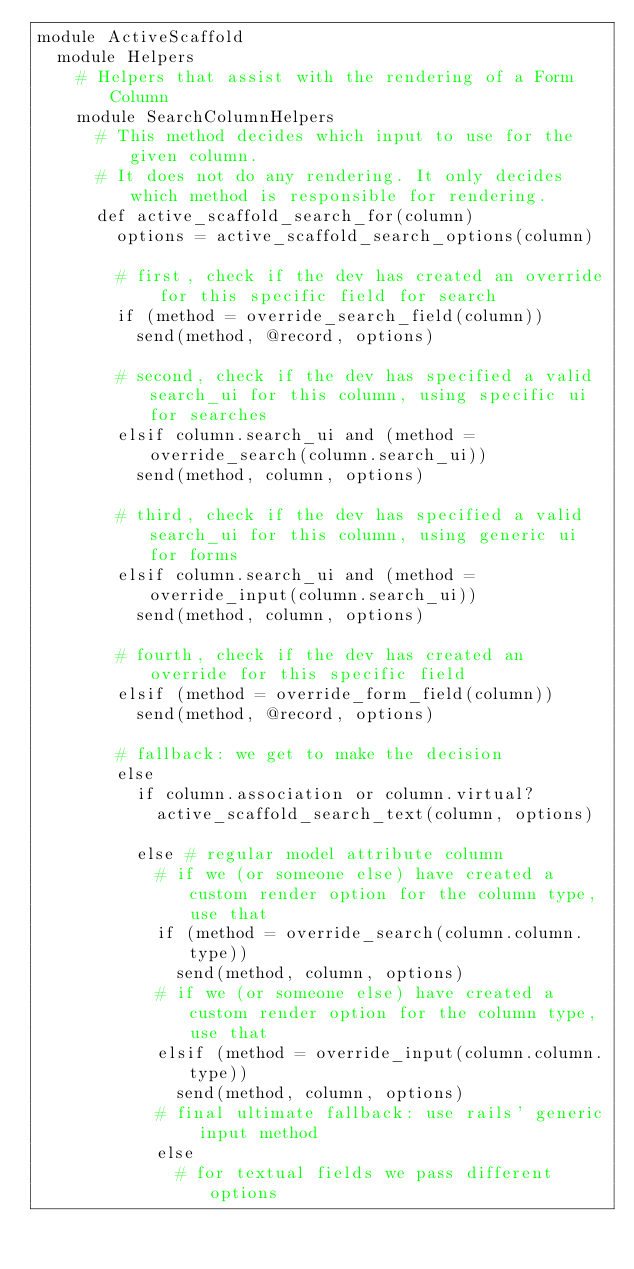<code> <loc_0><loc_0><loc_500><loc_500><_Ruby_>module ActiveScaffold
  module Helpers
    # Helpers that assist with the rendering of a Form Column
    module SearchColumnHelpers
      # This method decides which input to use for the given column.
      # It does not do any rendering. It only decides which method is responsible for rendering.
      def active_scaffold_search_for(column)
        options = active_scaffold_search_options(column)

        # first, check if the dev has created an override for this specific field for search
        if (method = override_search_field(column))
          send(method, @record, options)

        # second, check if the dev has specified a valid search_ui for this column, using specific ui for searches
        elsif column.search_ui and (method = override_search(column.search_ui))
          send(method, column, options)

        # third, check if the dev has specified a valid search_ui for this column, using generic ui for forms
        elsif column.search_ui and (method = override_input(column.search_ui))
          send(method, column, options)

        # fourth, check if the dev has created an override for this specific field
        elsif (method = override_form_field(column))
          send(method, @record, options)

        # fallback: we get to make the decision
        else
          if column.association or column.virtual?
            active_scaffold_search_text(column, options)

          else # regular model attribute column
            # if we (or someone else) have created a custom render option for the column type, use that
            if (method = override_search(column.column.type))
              send(method, column, options)
            # if we (or someone else) have created a custom render option for the column type, use that
            elsif (method = override_input(column.column.type))
              send(method, column, options)
            # final ultimate fallback: use rails' generic input method
            else
              # for textual fields we pass different options</code> 